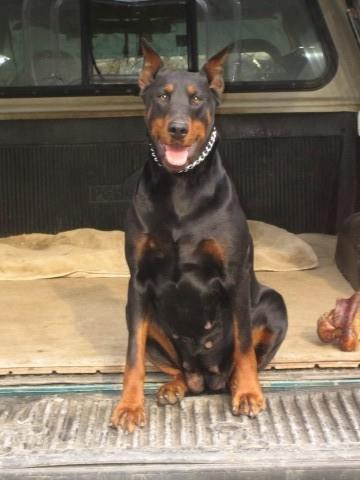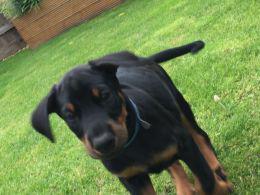The first image is the image on the left, the second image is the image on the right. Considering the images on both sides, is "There are an equal number of dogs in each image." valid? Answer yes or no. Yes. The first image is the image on the left, the second image is the image on the right. For the images displayed, is the sentence "Three dogs are present." factually correct? Answer yes or no. No. 